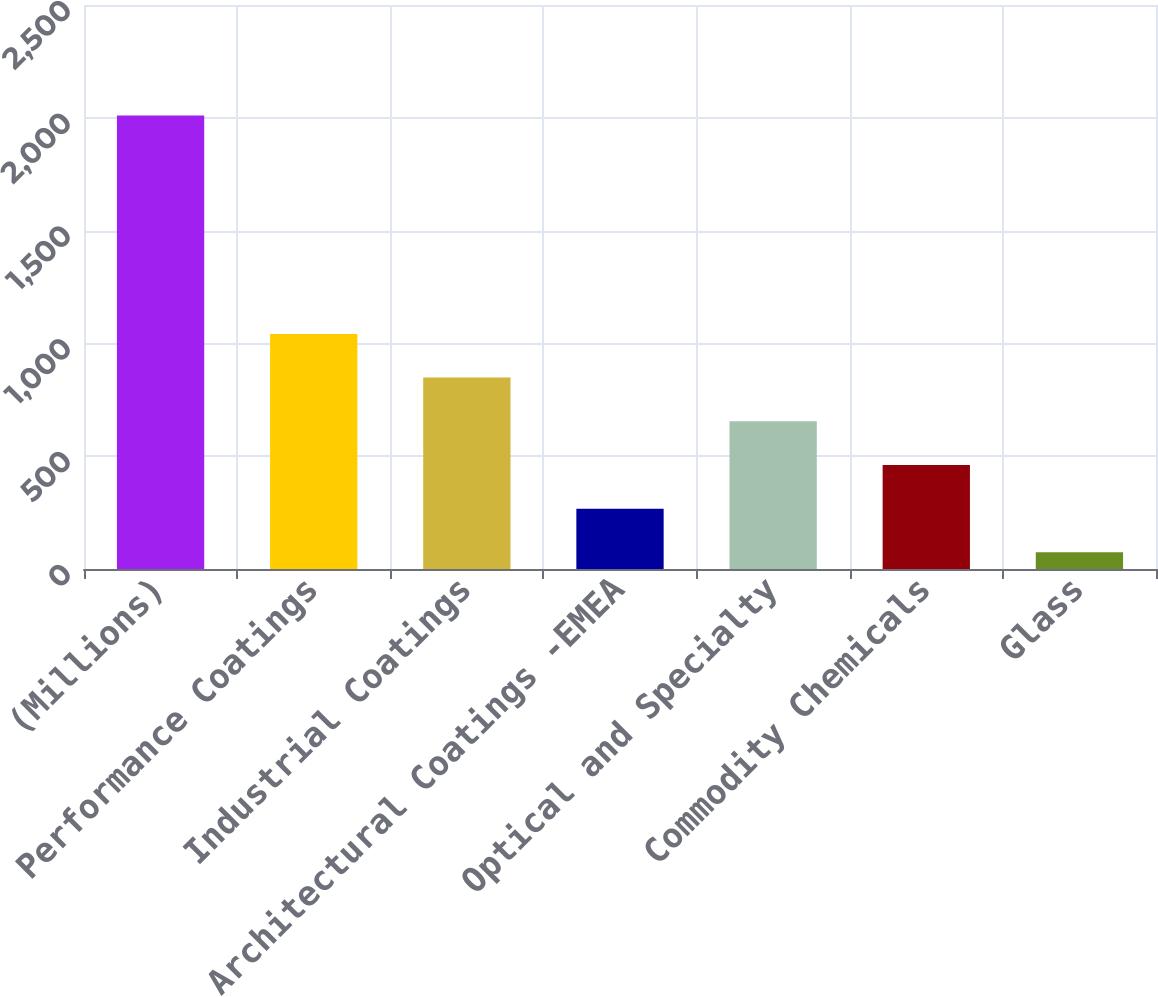Convert chart. <chart><loc_0><loc_0><loc_500><loc_500><bar_chart><fcel>(Millions)<fcel>Performance Coatings<fcel>Industrial Coatings<fcel>Architectural Coatings -EMEA<fcel>Optical and Specialty<fcel>Commodity Chemicals<fcel>Glass<nl><fcel>2010<fcel>1042<fcel>848.4<fcel>267.6<fcel>654.8<fcel>461.2<fcel>74<nl></chart> 